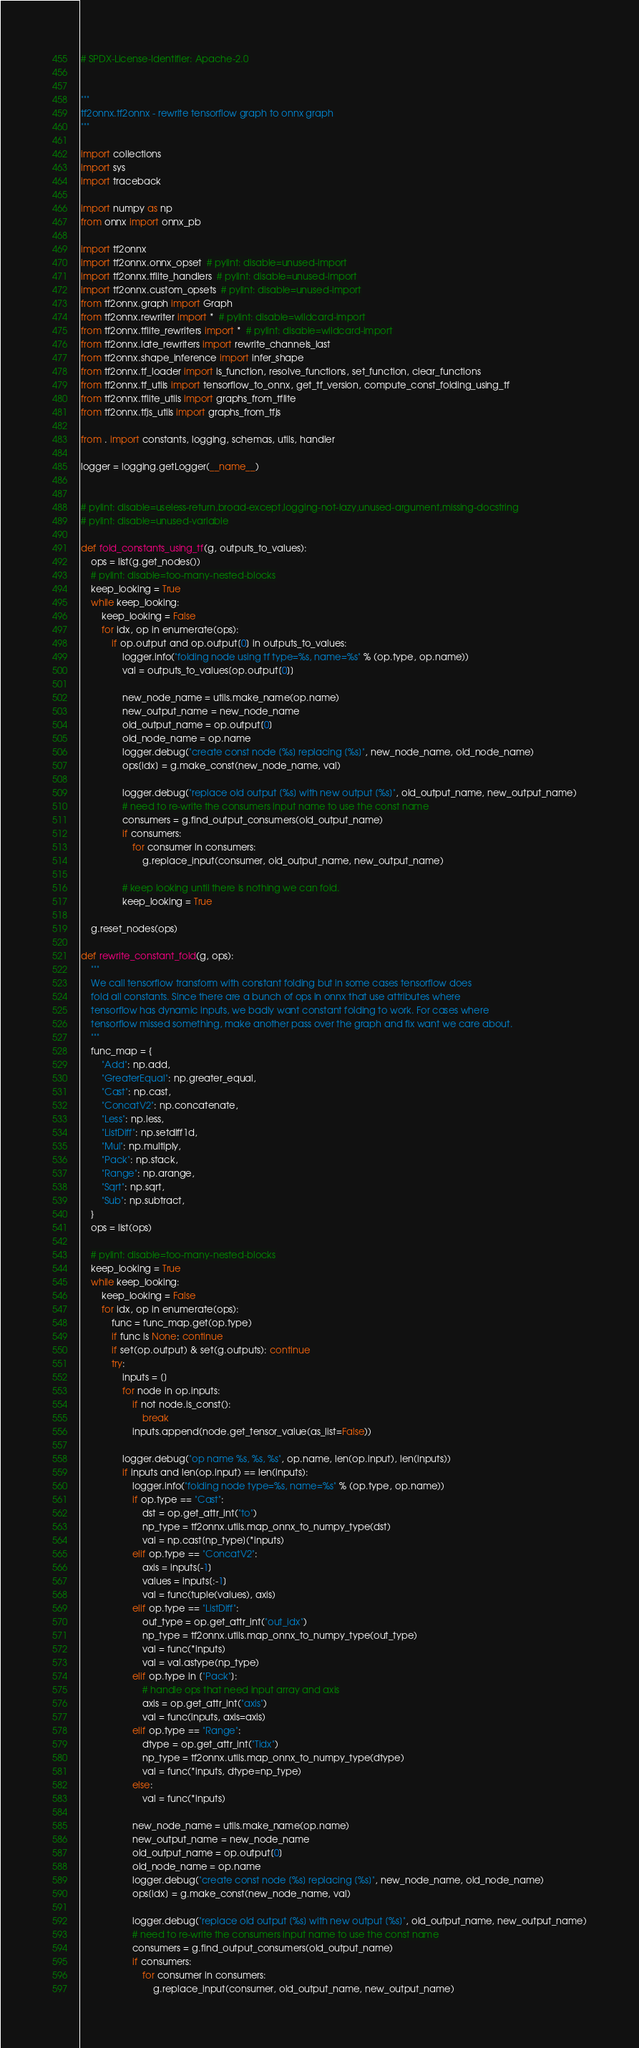Convert code to text. <code><loc_0><loc_0><loc_500><loc_500><_Python_># SPDX-License-Identifier: Apache-2.0


"""
tf2onnx.tf2onnx - rewrite tensorflow graph to onnx graph
"""

import collections
import sys
import traceback

import numpy as np
from onnx import onnx_pb

import tf2onnx
import tf2onnx.onnx_opset  # pylint: disable=unused-import
import tf2onnx.tflite_handlers  # pylint: disable=unused-import
import tf2onnx.custom_opsets  # pylint: disable=unused-import
from tf2onnx.graph import Graph
from tf2onnx.rewriter import *  # pylint: disable=wildcard-import
from tf2onnx.tflite_rewriters import *  # pylint: disable=wildcard-import
from tf2onnx.late_rewriters import rewrite_channels_last
from tf2onnx.shape_inference import infer_shape
from tf2onnx.tf_loader import is_function, resolve_functions, set_function, clear_functions
from tf2onnx.tf_utils import tensorflow_to_onnx, get_tf_version, compute_const_folding_using_tf
from tf2onnx.tflite_utils import graphs_from_tflite
from tf2onnx.tfjs_utils import graphs_from_tfjs

from . import constants, logging, schemas, utils, handler

logger = logging.getLogger(__name__)


# pylint: disable=useless-return,broad-except,logging-not-lazy,unused-argument,missing-docstring
# pylint: disable=unused-variable

def fold_constants_using_tf(g, outputs_to_values):
    ops = list(g.get_nodes())
    # pylint: disable=too-many-nested-blocks
    keep_looking = True
    while keep_looking:
        keep_looking = False
        for idx, op in enumerate(ops):
            if op.output and op.output[0] in outputs_to_values:
                logger.info("folding node using tf type=%s, name=%s" % (op.type, op.name))
                val = outputs_to_values[op.output[0]]

                new_node_name = utils.make_name(op.name)
                new_output_name = new_node_name
                old_output_name = op.output[0]
                old_node_name = op.name
                logger.debug("create const node [%s] replacing [%s]", new_node_name, old_node_name)
                ops[idx] = g.make_const(new_node_name, val)

                logger.debug("replace old output [%s] with new output [%s]", old_output_name, new_output_name)
                # need to re-write the consumers input name to use the const name
                consumers = g.find_output_consumers(old_output_name)
                if consumers:
                    for consumer in consumers:
                        g.replace_input(consumer, old_output_name, new_output_name)

                # keep looking until there is nothing we can fold.
                keep_looking = True

    g.reset_nodes(ops)

def rewrite_constant_fold(g, ops):
    """
    We call tensorflow transform with constant folding but in some cases tensorflow does
    fold all constants. Since there are a bunch of ops in onnx that use attributes where
    tensorflow has dynamic inputs, we badly want constant folding to work. For cases where
    tensorflow missed something, make another pass over the graph and fix want we care about.
    """
    func_map = {
        "Add": np.add,
        "GreaterEqual": np.greater_equal,
        "Cast": np.cast,
        "ConcatV2": np.concatenate,
        "Less": np.less,
        "ListDiff": np.setdiff1d,
        "Mul": np.multiply,
        "Pack": np.stack,
        "Range": np.arange,
        "Sqrt": np.sqrt,
        "Sub": np.subtract,
    }
    ops = list(ops)

    # pylint: disable=too-many-nested-blocks
    keep_looking = True
    while keep_looking:
        keep_looking = False
        for idx, op in enumerate(ops):
            func = func_map.get(op.type)
            if func is None: continue
            if set(op.output) & set(g.outputs): continue
            try:
                inputs = []
                for node in op.inputs:
                    if not node.is_const():
                        break
                    inputs.append(node.get_tensor_value(as_list=False))

                logger.debug("op name %s, %s, %s", op.name, len(op.input), len(inputs))
                if inputs and len(op.input) == len(inputs):
                    logger.info("folding node type=%s, name=%s" % (op.type, op.name))
                    if op.type == "Cast":
                        dst = op.get_attr_int("to")
                        np_type = tf2onnx.utils.map_onnx_to_numpy_type(dst)
                        val = np.cast[np_type](*inputs)
                    elif op.type == "ConcatV2":
                        axis = inputs[-1]
                        values = inputs[:-1]
                        val = func(tuple(values), axis)
                    elif op.type == "ListDiff":
                        out_type = op.get_attr_int("out_idx")
                        np_type = tf2onnx.utils.map_onnx_to_numpy_type(out_type)
                        val = func(*inputs)
                        val = val.astype(np_type)
                    elif op.type in ["Pack"]:
                        # handle ops that need input array and axis
                        axis = op.get_attr_int("axis")
                        val = func(inputs, axis=axis)
                    elif op.type == "Range":
                        dtype = op.get_attr_int("Tidx")
                        np_type = tf2onnx.utils.map_onnx_to_numpy_type(dtype)
                        val = func(*inputs, dtype=np_type)
                    else:
                        val = func(*inputs)

                    new_node_name = utils.make_name(op.name)
                    new_output_name = new_node_name
                    old_output_name = op.output[0]
                    old_node_name = op.name
                    logger.debug("create const node [%s] replacing [%s]", new_node_name, old_node_name)
                    ops[idx] = g.make_const(new_node_name, val)

                    logger.debug("replace old output [%s] with new output [%s]", old_output_name, new_output_name)
                    # need to re-write the consumers input name to use the const name
                    consumers = g.find_output_consumers(old_output_name)
                    if consumers:
                        for consumer in consumers:
                            g.replace_input(consumer, old_output_name, new_output_name)
</code> 